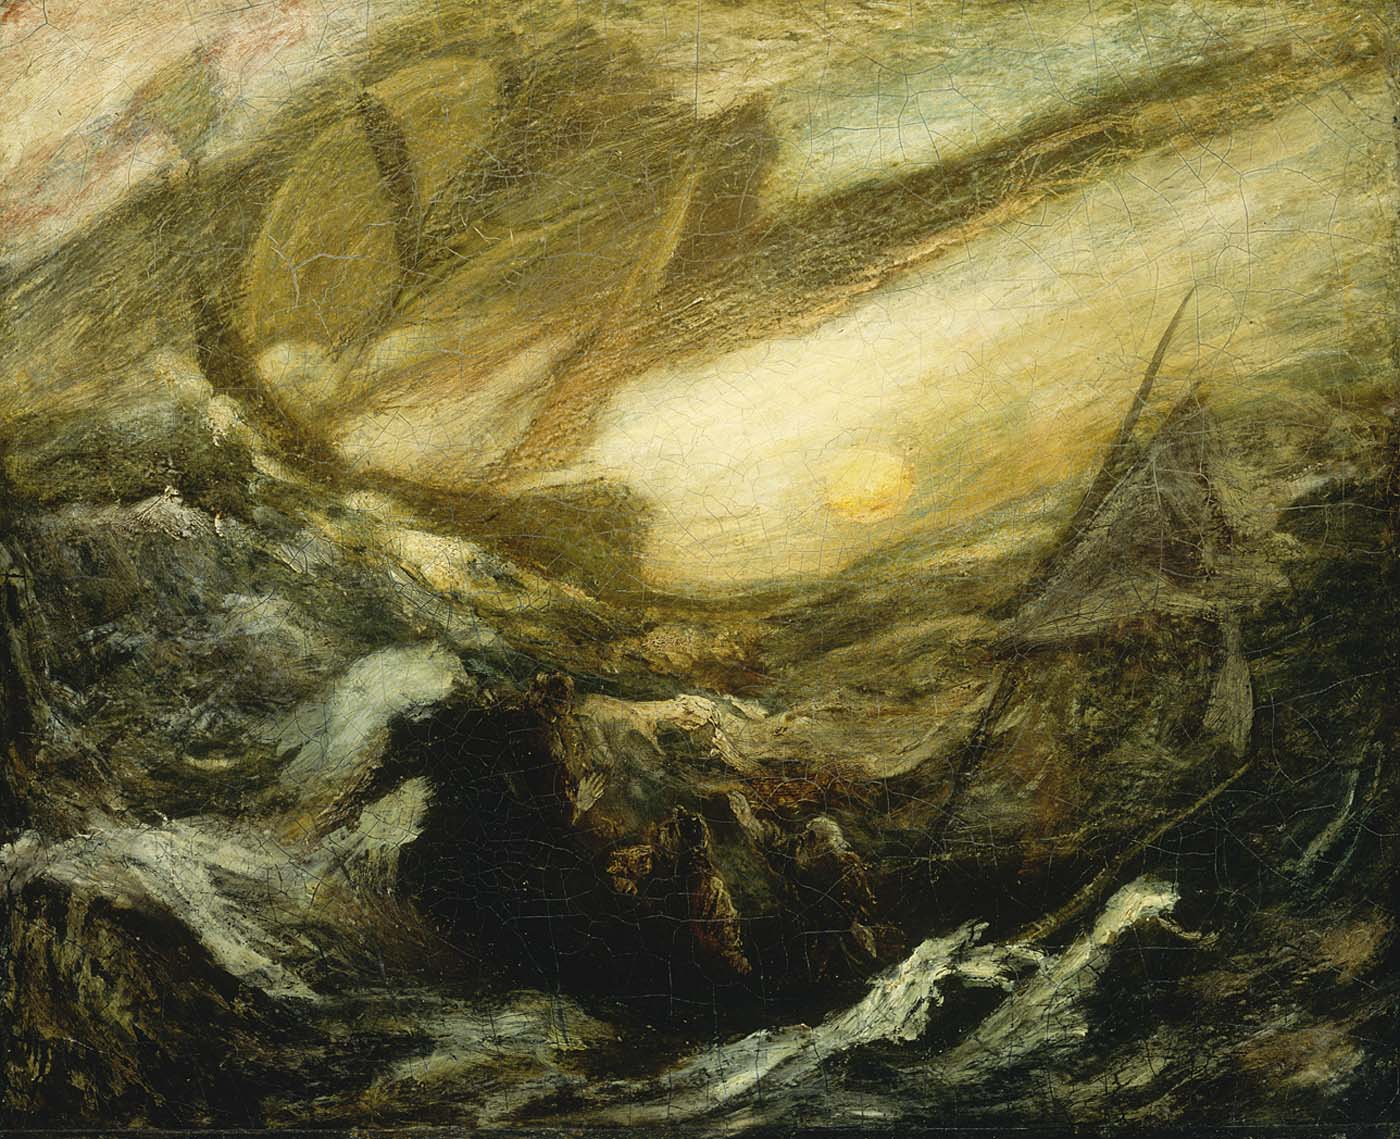Create a poetic interpretation of this painting. Amidst the chaos of the sea's embrace,
Where darkness roils and tempests race,
A fiery sun with golden grace,
Breaks through the sky, a guiding face.
Waves like monsters, fierce and wide,
Crash and roar with relentless pride,
Yet through the storm I cannot hide,
I’m drawn to where the hopes abide.
In this turmoil, a dance of might,
Between the shadow and the light,
A testament to the endless fight,
In nature’s realm, wild and bright.
A sailor’s heart, though full of fright,
Beholds the sun, a beacon bright,
Through the chaos, amidst the night,
Navigates with every sight. 